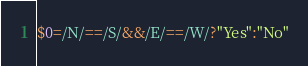Convert code to text. <code><loc_0><loc_0><loc_500><loc_500><_Awk_>$0=/N/==/S/&&/E/==/W/?"Yes":"No"</code> 